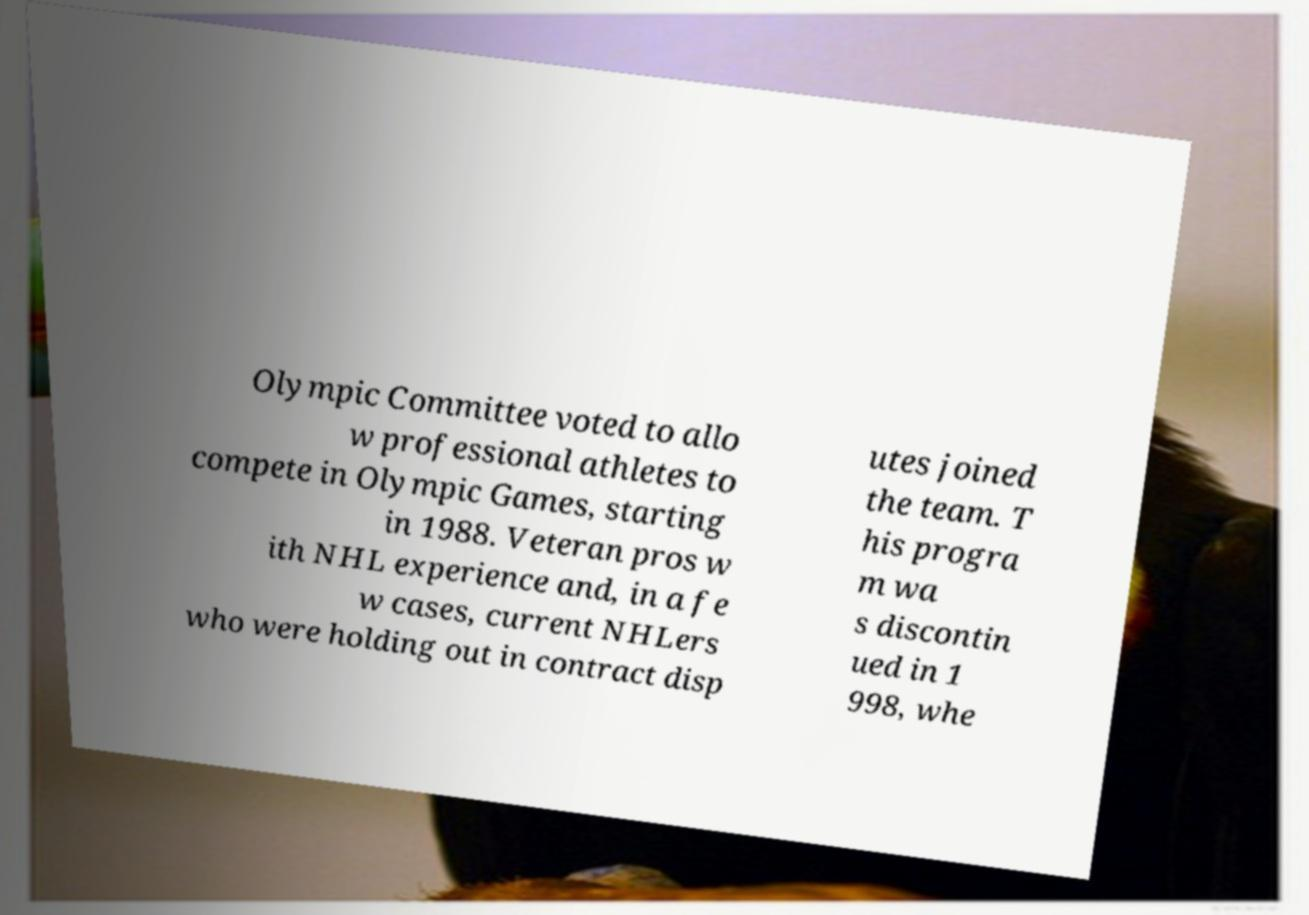What messages or text are displayed in this image? I need them in a readable, typed format. Olympic Committee voted to allo w professional athletes to compete in Olympic Games, starting in 1988. Veteran pros w ith NHL experience and, in a fe w cases, current NHLers who were holding out in contract disp utes joined the team. T his progra m wa s discontin ued in 1 998, whe 